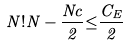Convert formula to latex. <formula><loc_0><loc_0><loc_500><loc_500>N ! N - \frac { N c } { 2 } { \leq } \frac { C _ { E } } { 2 }</formula> 